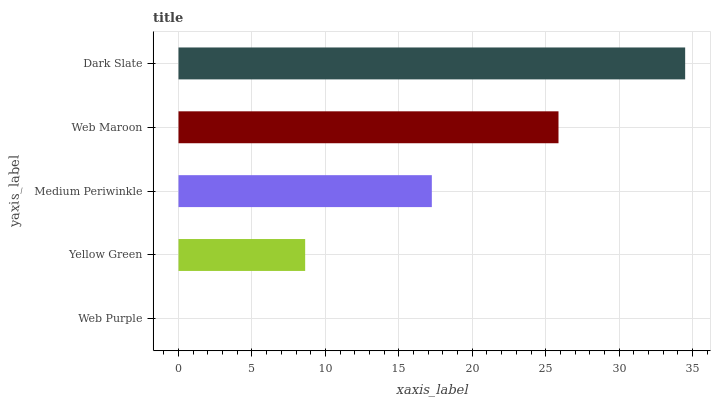Is Web Purple the minimum?
Answer yes or no. Yes. Is Dark Slate the maximum?
Answer yes or no. Yes. Is Yellow Green the minimum?
Answer yes or no. No. Is Yellow Green the maximum?
Answer yes or no. No. Is Yellow Green greater than Web Purple?
Answer yes or no. Yes. Is Web Purple less than Yellow Green?
Answer yes or no. Yes. Is Web Purple greater than Yellow Green?
Answer yes or no. No. Is Yellow Green less than Web Purple?
Answer yes or no. No. Is Medium Periwinkle the high median?
Answer yes or no. Yes. Is Medium Periwinkle the low median?
Answer yes or no. Yes. Is Web Purple the high median?
Answer yes or no. No. Is Web Maroon the low median?
Answer yes or no. No. 